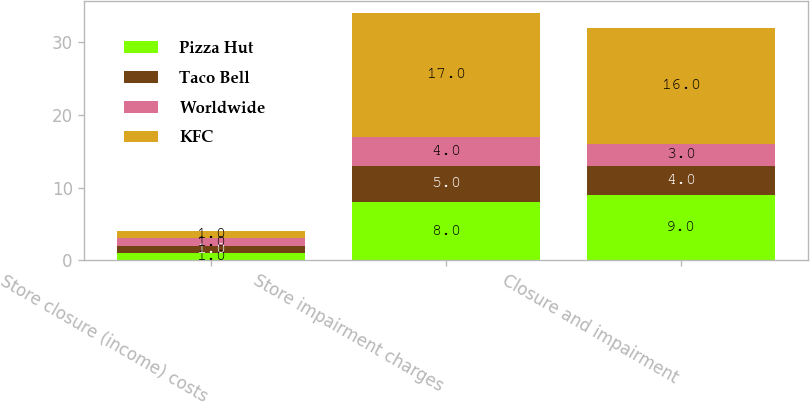Convert chart to OTSL. <chart><loc_0><loc_0><loc_500><loc_500><stacked_bar_chart><ecel><fcel>Store closure (income) costs<fcel>Store impairment charges<fcel>Closure and impairment<nl><fcel>Pizza Hut<fcel>1<fcel>8<fcel>9<nl><fcel>Taco Bell<fcel>1<fcel>5<fcel>4<nl><fcel>Worldwide<fcel>1<fcel>4<fcel>3<nl><fcel>KFC<fcel>1<fcel>17<fcel>16<nl></chart> 